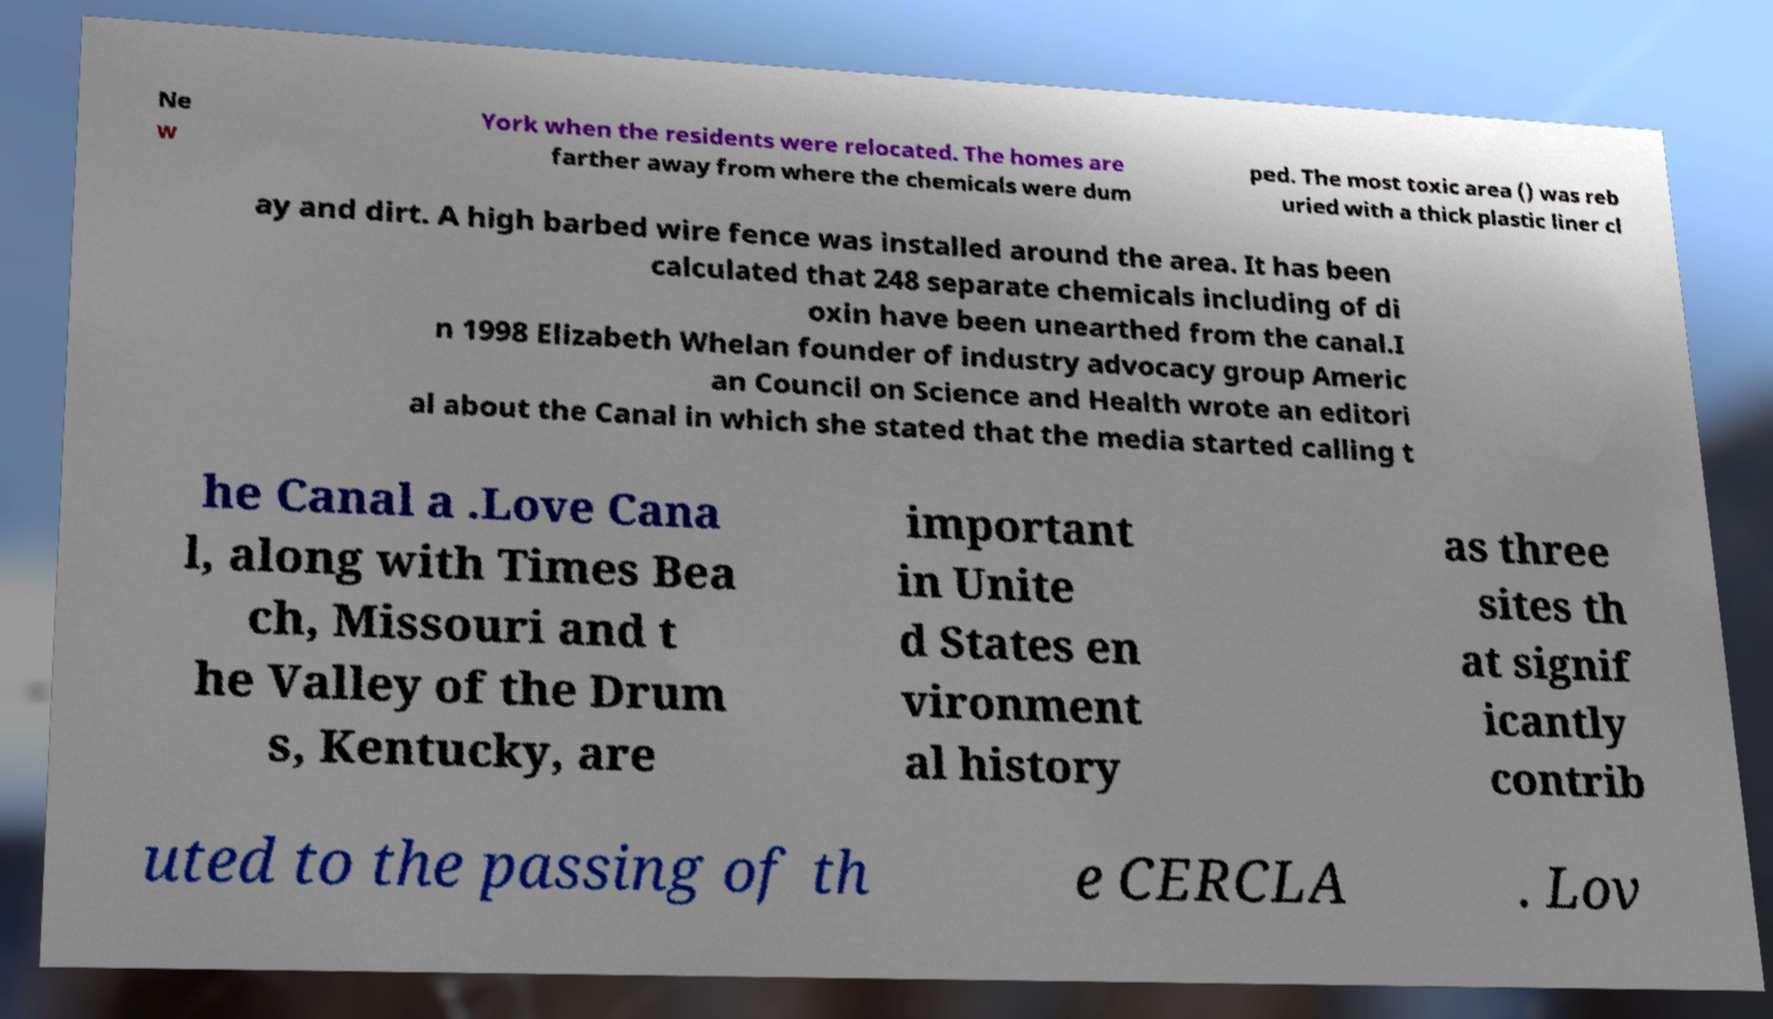Could you extract and type out the text from this image? Ne w York when the residents were relocated. The homes are farther away from where the chemicals were dum ped. The most toxic area () was reb uried with a thick plastic liner cl ay and dirt. A high barbed wire fence was installed around the area. It has been calculated that 248 separate chemicals including of di oxin have been unearthed from the canal.I n 1998 Elizabeth Whelan founder of industry advocacy group Americ an Council on Science and Health wrote an editori al about the Canal in which she stated that the media started calling t he Canal a .Love Cana l, along with Times Bea ch, Missouri and t he Valley of the Drum s, Kentucky, are important in Unite d States en vironment al history as three sites th at signif icantly contrib uted to the passing of th e CERCLA . Lov 